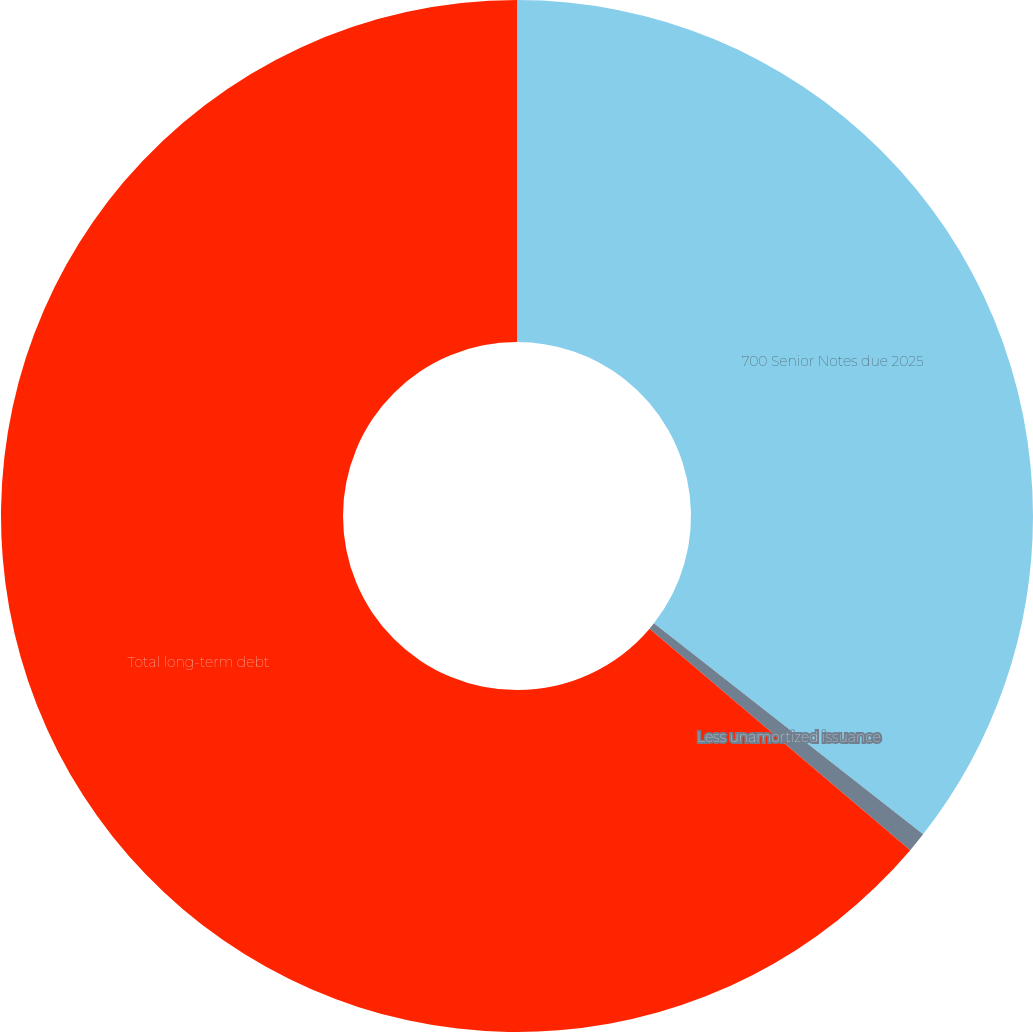Convert chart. <chart><loc_0><loc_0><loc_500><loc_500><pie_chart><fcel>700 Senior Notes due 2025<fcel>Less unamortized issuance<fcel>Total long-term debt<nl><fcel>35.58%<fcel>0.63%<fcel>63.79%<nl></chart> 